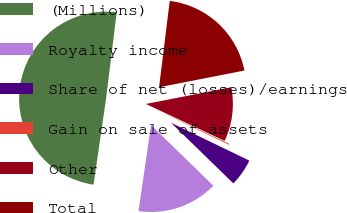Convert chart to OTSL. <chart><loc_0><loc_0><loc_500><loc_500><pie_chart><fcel>(Millions)<fcel>Royalty income<fcel>Share of net (losses)/earnings<fcel>Gain on sale of assets<fcel>Other<fcel>Total<nl><fcel>49.65%<fcel>15.02%<fcel>5.12%<fcel>0.17%<fcel>10.07%<fcel>19.97%<nl></chart> 